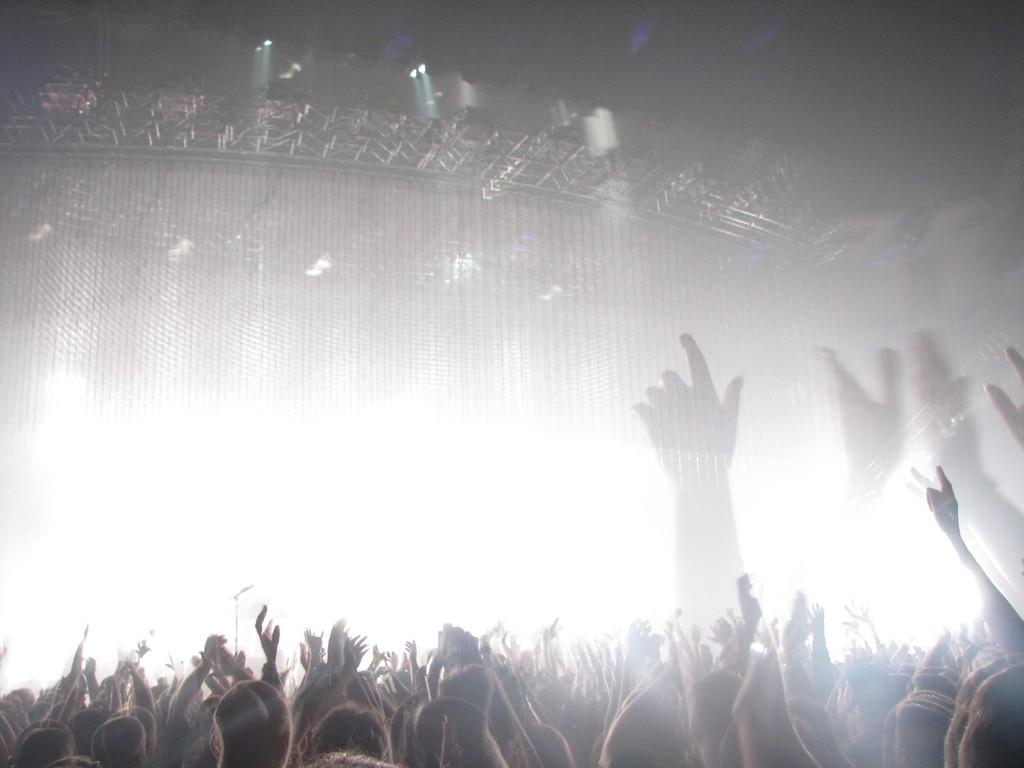What is happening with the group of persons in the image? The group of persons are cheering in the image. What might be the reason for their cheering? We cannot determine the reason for their cheering from the image alone. What is located in the image besides the group of persons? There is a dais in the image. What can be seen in the background of the image? There are lights in the background of the image. How many straws are being used by the brothers on the committee in the image? There are no straws, brothers, or committee mentioned or depicted in the image. 